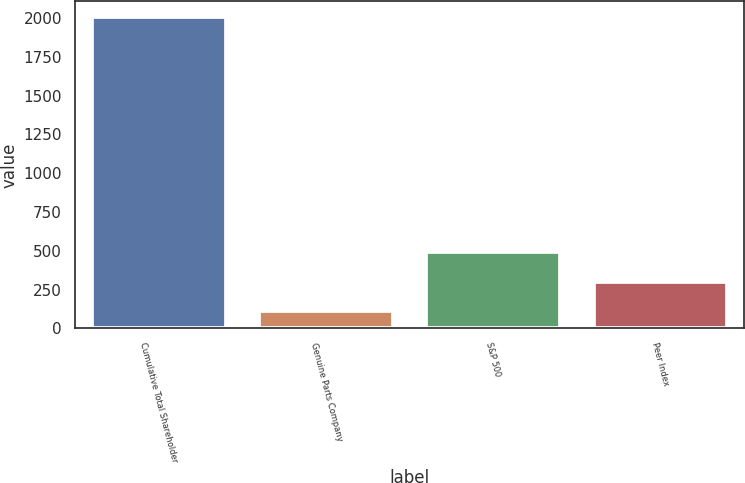<chart> <loc_0><loc_0><loc_500><loc_500><bar_chart><fcel>Cumulative Total Shareholder<fcel>Genuine Parts Company<fcel>S&P 500<fcel>Peer Index<nl><fcel>2007<fcel>112.03<fcel>491.03<fcel>301.53<nl></chart> 